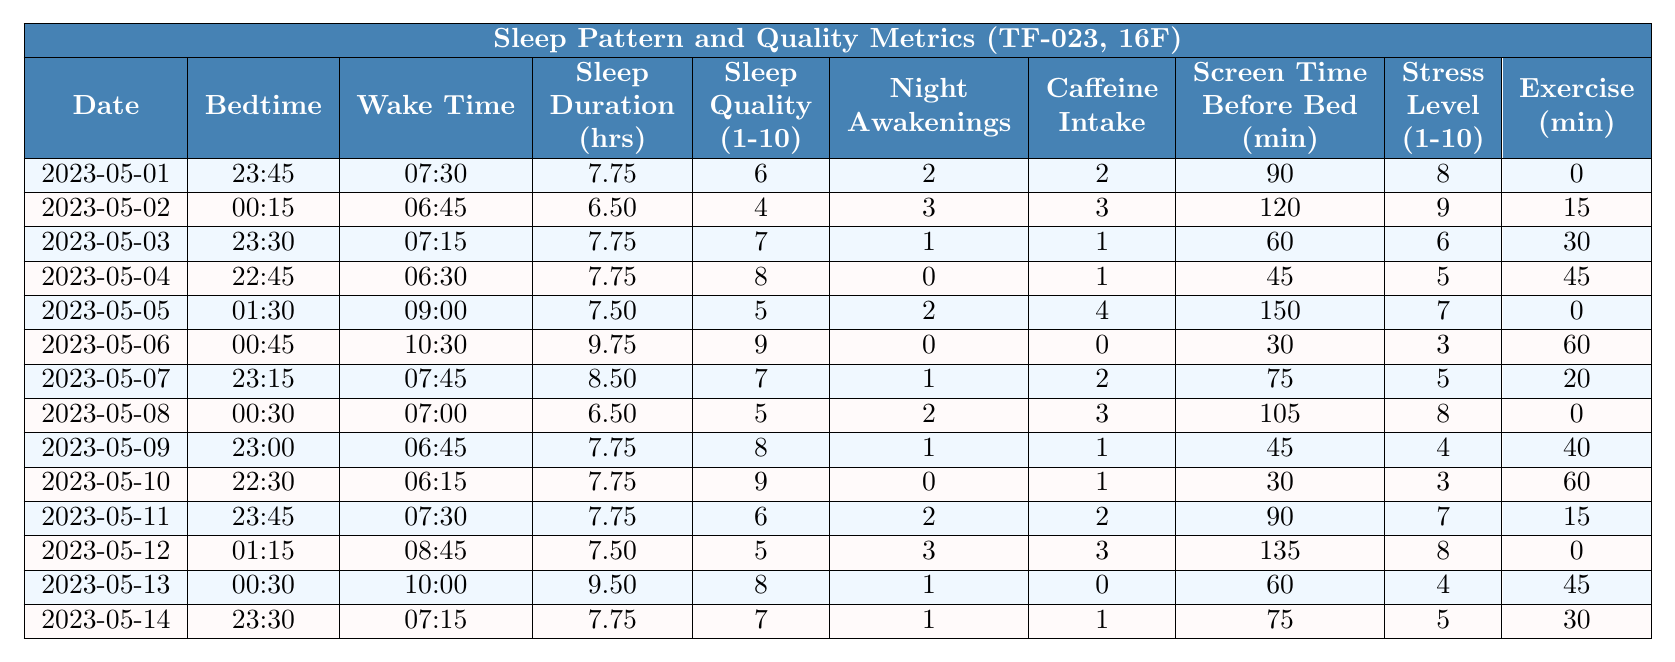What was the longest total sleep duration recorded? The longest total sleep duration recorded was on 2023-05-06 at 9.75 hours.
Answer: 9.75 hours On which date did the participant have the highest sleep quality score? The highest sleep quality score of 9 was recorded on 2023-05-06.
Answer: 9 What was the average total sleep duration over the two weeks? To find the average, sum the total sleep durations (7.75 + 6.5 + 7.75 + 7.75 + 7.5 + 9.75 + 8.5 + 6.5 + 7.75 + 7.75 + 7.75 + 7.5 + 9.5 + 7.75) which equals 106.25. Then, divide by 14 days to get an average of 106.25/14 = 7.59 hours.
Answer: 7.59 hours Was there a day when the participant experienced zero nighttime awakenings? Yes, on 2023-05-06, the participant experienced zero nighttime awakenings.
Answer: Yes What is the total amount of caffeine consumed over the two-week period? To find the total caffeine, sum the daily caffeine intakes: (2 + 3 + 1 + 1 + 4 + 0 + 2 + 3 + 1 + 1 + 2 + 3 + 0 + 1) which equals 25.
Answer: 25 On which date did the participant have the least amount of exercise? The least amount of exercise was on 2023-05-01 and 2023-05-05, where exercise minutes were 0.
Answer: 2023-05-01 and 2023-05-05 What was the relationship between stress levels and sleep quality during this study? Stress levels were generally higher on days where sleep quality scores were lower, suggesting an inverse relationship. For example, on 2023-05-02 stress was at 9 with sleep quality of 4; on 2023-05-06, stress was at 3 with a quality of 9.
Answer: Inverse relationship What date saw the most significant decrease in sleep duration compared to the previous day? The largest decrease was on 2023-05-02, where sleep duration dropped from 7.75 hours on 2023-05-01 to 6.5 hours on 2023-05-02, a decrease of 1.25 hours.
Answer: 2023-05-02 How many days had a sleep quality score of 5 or lower? The sleep quality scores of 5 or lower occurred on 2023-05-02, 2023-05-05, 2023-05-08, 2023-05-12, totaling four days.
Answer: Four days What differences can be observed in caffeine consumption between the best and worst sleep quality days? On the best sleep quality day (2023-05-06, quality score of 9), caffeine consumption was 0. On the worst sleep quality day (2023-05-02, quality score of 4), caffeine consumption was 3. This shows a difference of 3.
Answer: Difference of 3 